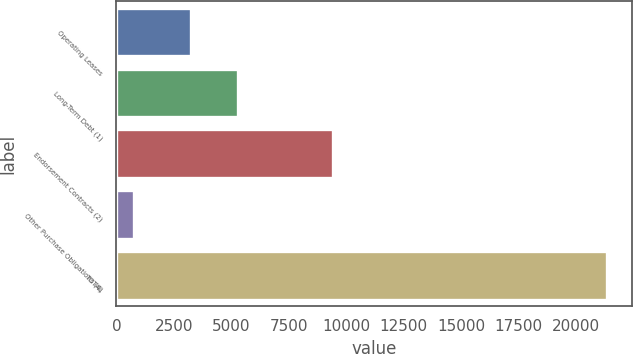<chart> <loc_0><loc_0><loc_500><loc_500><bar_chart><fcel>Operating Leases<fcel>Long-Term Debt (1)<fcel>Endorsement Contracts (2)<fcel>Other Purchase Obligations (4)<fcel>TOTAL<nl><fcel>3231<fcel>5289.9<fcel>9420<fcel>772<fcel>21361<nl></chart> 